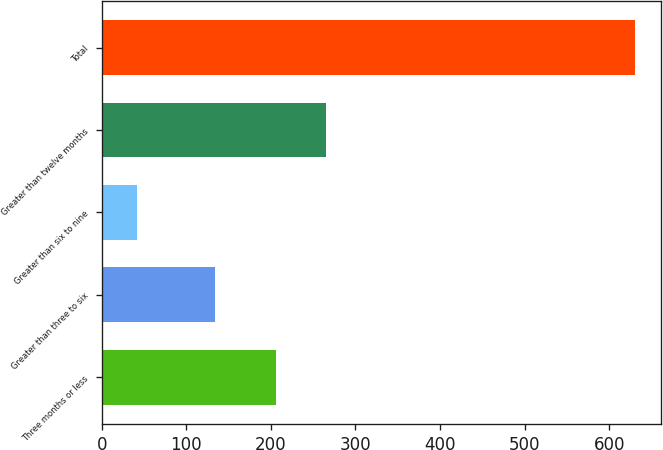<chart> <loc_0><loc_0><loc_500><loc_500><bar_chart><fcel>Three months or less<fcel>Greater than three to six<fcel>Greater than six to nine<fcel>Greater than twelve months<fcel>Total<nl><fcel>206<fcel>134<fcel>42<fcel>264.8<fcel>630<nl></chart> 